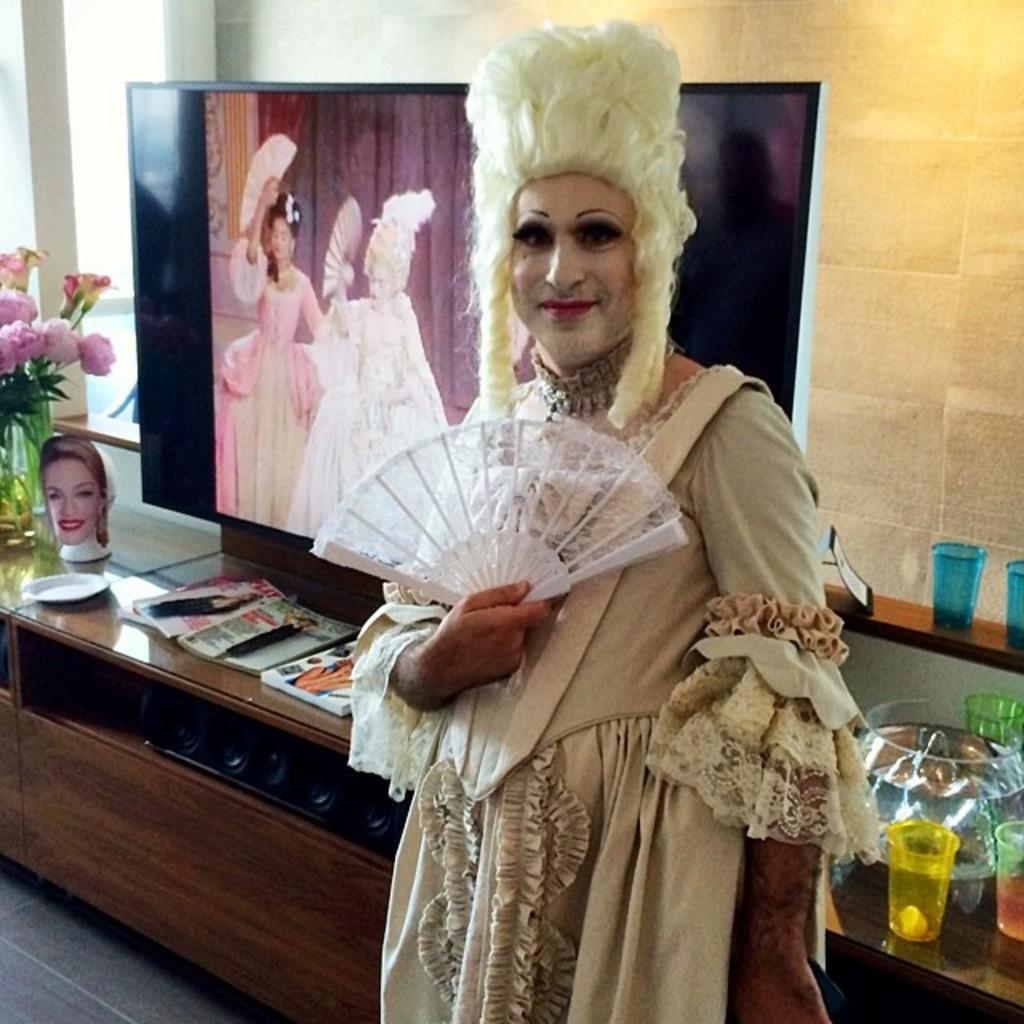In one or two sentences, can you explain what this image depicts? In the center of the image we can see a person standing and holding a fan. He is wearing a costume. In the background there is a table and we can see glasses, jar, books, flower vase and some objects placed on the table. We can see a screen and there is a wall. 